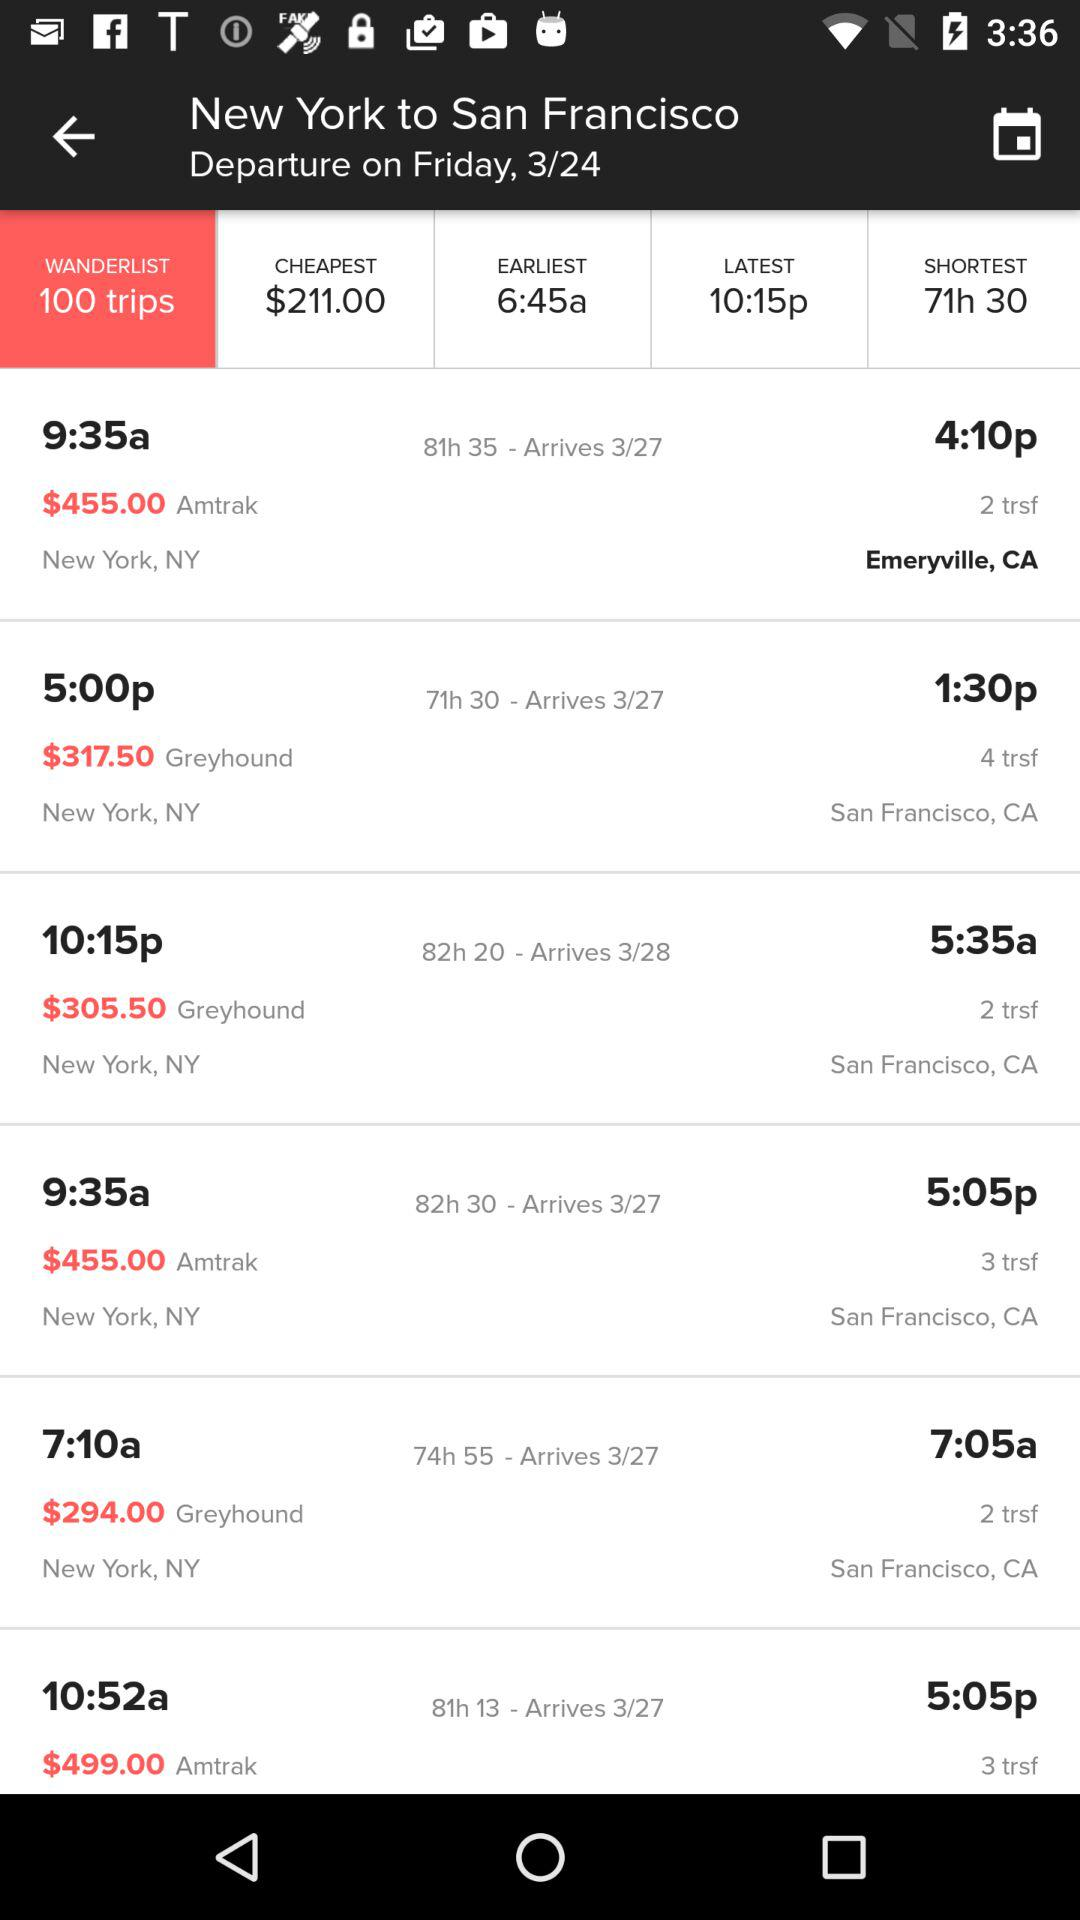What is the departure date? The departure date is Friday, March 24. 